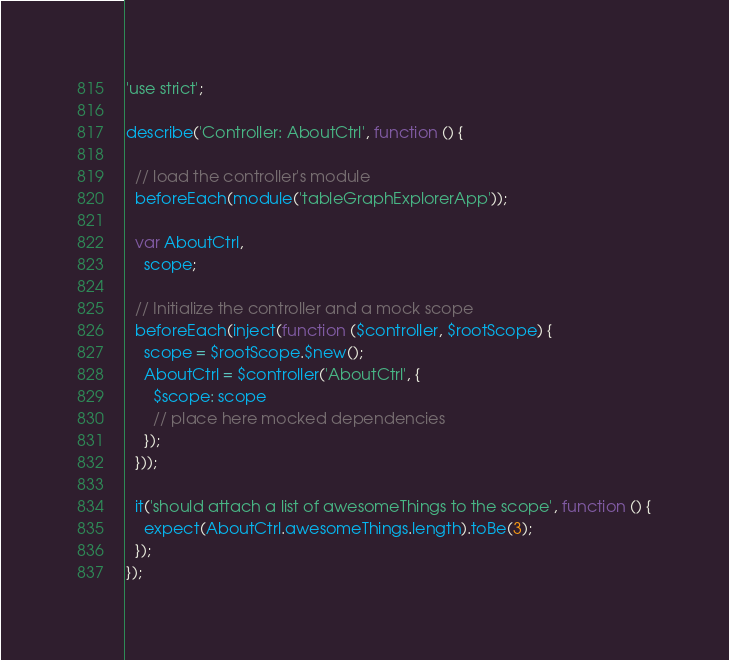Convert code to text. <code><loc_0><loc_0><loc_500><loc_500><_JavaScript_>'use strict';

describe('Controller: AboutCtrl', function () {

  // load the controller's module
  beforeEach(module('tableGraphExplorerApp'));

  var AboutCtrl,
    scope;

  // Initialize the controller and a mock scope
  beforeEach(inject(function ($controller, $rootScope) {
    scope = $rootScope.$new();
    AboutCtrl = $controller('AboutCtrl', {
      $scope: scope
      // place here mocked dependencies
    });
  }));

  it('should attach a list of awesomeThings to the scope', function () {
    expect(AboutCtrl.awesomeThings.length).toBe(3);
  });
});
</code> 